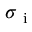Convert formula to latex. <formula><loc_0><loc_0><loc_500><loc_500>\sigma _ { i }</formula> 